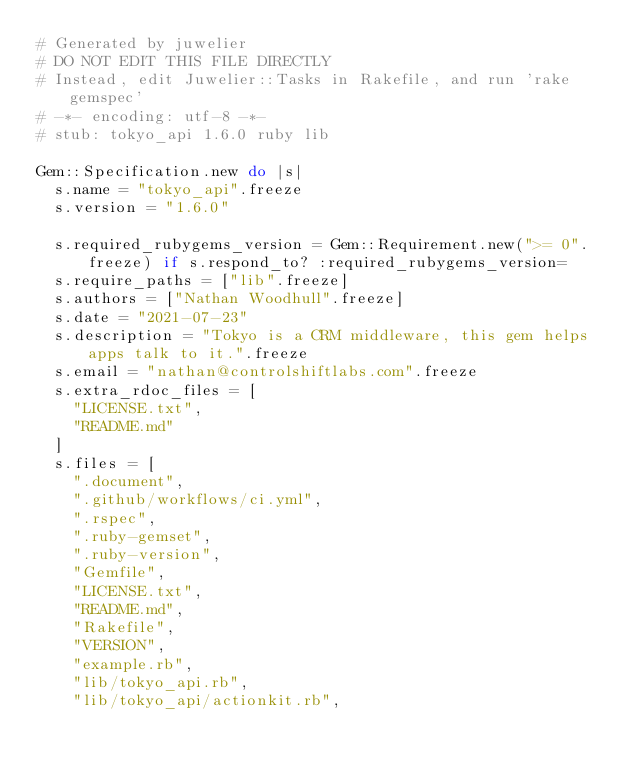<code> <loc_0><loc_0><loc_500><loc_500><_Ruby_># Generated by juwelier
# DO NOT EDIT THIS FILE DIRECTLY
# Instead, edit Juwelier::Tasks in Rakefile, and run 'rake gemspec'
# -*- encoding: utf-8 -*-
# stub: tokyo_api 1.6.0 ruby lib

Gem::Specification.new do |s|
  s.name = "tokyo_api".freeze
  s.version = "1.6.0"

  s.required_rubygems_version = Gem::Requirement.new(">= 0".freeze) if s.respond_to? :required_rubygems_version=
  s.require_paths = ["lib".freeze]
  s.authors = ["Nathan Woodhull".freeze]
  s.date = "2021-07-23"
  s.description = "Tokyo is a CRM middleware, this gem helps apps talk to it.".freeze
  s.email = "nathan@controlshiftlabs.com".freeze
  s.extra_rdoc_files = [
    "LICENSE.txt",
    "README.md"
  ]
  s.files = [
    ".document",
    ".github/workflows/ci.yml",
    ".rspec",
    ".ruby-gemset",
    ".ruby-version",
    "Gemfile",
    "LICENSE.txt",
    "README.md",
    "Rakefile",
    "VERSION",
    "example.rb",
    "lib/tokyo_api.rb",
    "lib/tokyo_api/actionkit.rb",</code> 